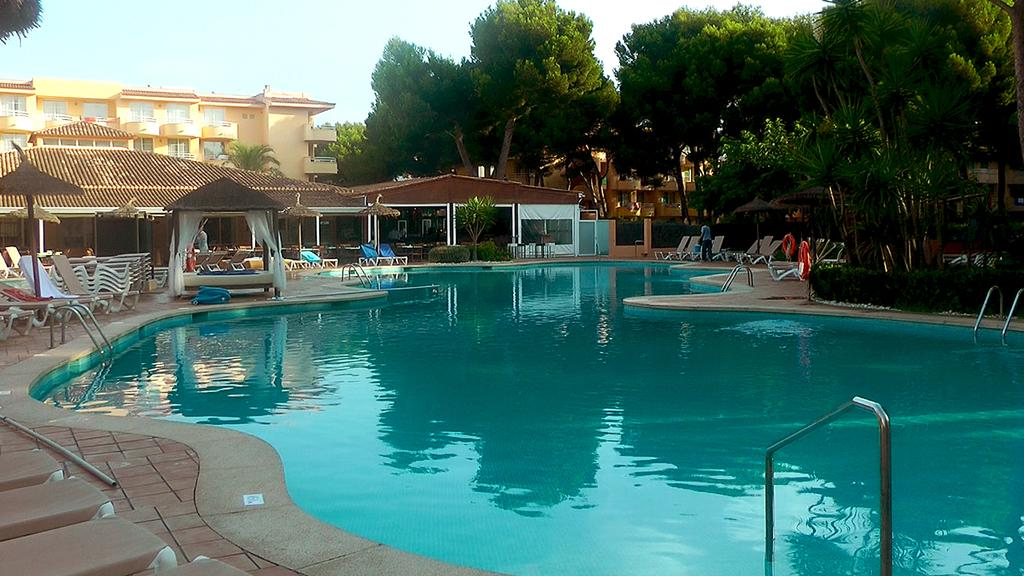What is the main feature of the image? There is a swimming pool in the image. What structures are present near the swimming pool? Handrails, chairs, an umbrella, and a bed are visible in the image. What type of vegetation is present in the image? Plants and trees are present in the image. What other structures can be seen in the image? Sheds and buildings are present in the image. Are there any people in the image? Yes, people are visible in the image. What can be seen in the background of the image? The sky is visible in the background of the image. What type of society is depicted in the image? The image does not depict a society; it features a swimming pool and related structures and objects. What error can be seen in the image? There is no error present in the image; it accurately represents the scene. 